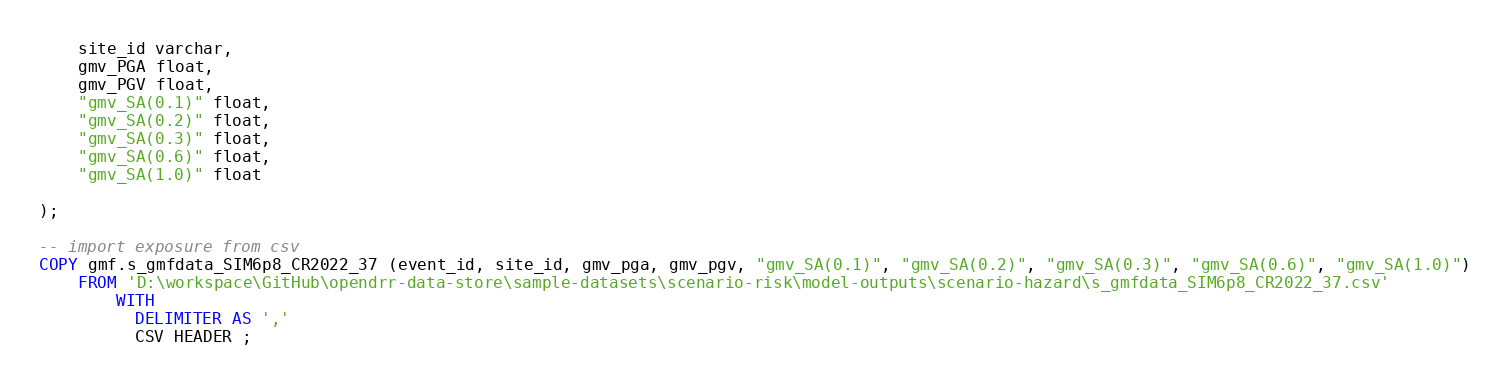Convert code to text. <code><loc_0><loc_0><loc_500><loc_500><_SQL_>    site_id varchar,
    gmv_PGA float,
    gmv_PGV float,
    "gmv_SA(0.1)" float,
    "gmv_SA(0.2)" float,
    "gmv_SA(0.3)" float,
    "gmv_SA(0.6)" float,
    "gmv_SA(1.0)" float
    
);

-- import exposure from csv
COPY gmf.s_gmfdata_SIM6p8_CR2022_37 (event_id, site_id, gmv_pga, gmv_pgv, "gmv_SA(0.1)", "gmv_SA(0.2)", "gmv_SA(0.3)", "gmv_SA(0.6)", "gmv_SA(1.0)")
    FROM 'D:\workspace\GitHub\opendrr-data-store\sample-datasets\scenario-risk\model-outputs\scenario-hazard\s_gmfdata_SIM6p8_CR2022_37.csv'
        WITH 
          DELIMITER AS ','
          CSV HEADER ;</code> 